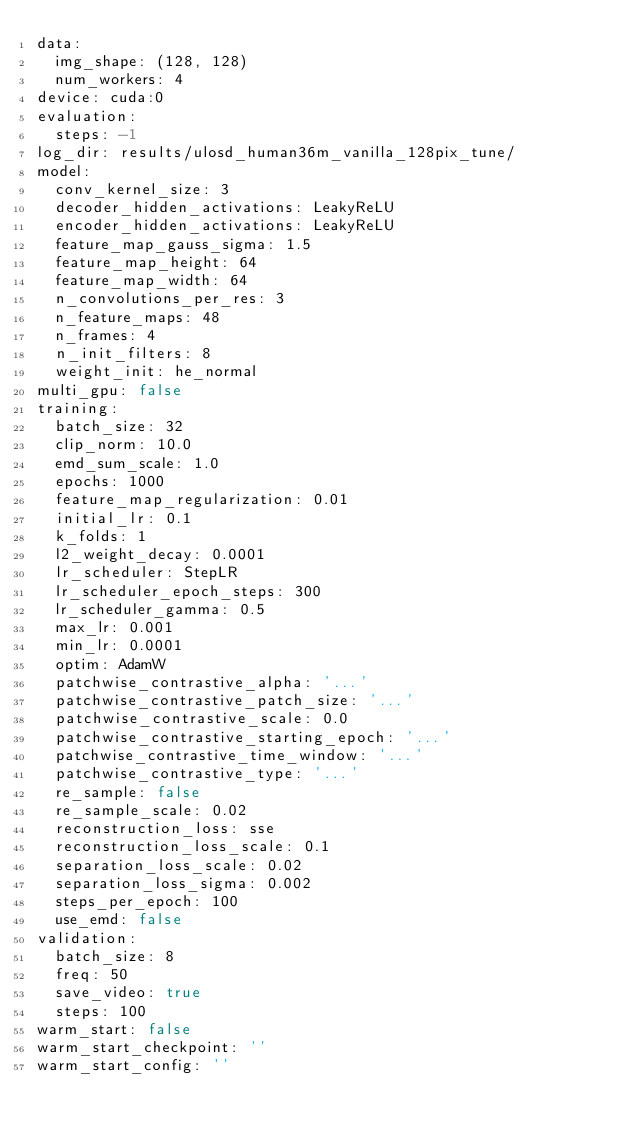Convert code to text. <code><loc_0><loc_0><loc_500><loc_500><_YAML_>data:
  img_shape: (128, 128)
  num_workers: 4
device: cuda:0
evaluation:
  steps: -1
log_dir: results/ulosd_human36m_vanilla_128pix_tune/
model:
  conv_kernel_size: 3
  decoder_hidden_activations: LeakyReLU
  encoder_hidden_activations: LeakyReLU
  feature_map_gauss_sigma: 1.5
  feature_map_height: 64
  feature_map_width: 64
  n_convolutions_per_res: 3
  n_feature_maps: 48
  n_frames: 4
  n_init_filters: 8
  weight_init: he_normal
multi_gpu: false
training:
  batch_size: 32
  clip_norm: 10.0
  emd_sum_scale: 1.0
  epochs: 1000
  feature_map_regularization: 0.01
  initial_lr: 0.1
  k_folds: 1
  l2_weight_decay: 0.0001
  lr_scheduler: StepLR
  lr_scheduler_epoch_steps: 300
  lr_scheduler_gamma: 0.5
  max_lr: 0.001
  min_lr: 0.0001
  optim: AdamW
  patchwise_contrastive_alpha: '...'
  patchwise_contrastive_patch_size: '...'
  patchwise_contrastive_scale: 0.0
  patchwise_contrastive_starting_epoch: '...'
  patchwise_contrastive_time_window: '...'
  patchwise_contrastive_type: '...'
  re_sample: false
  re_sample_scale: 0.02
  reconstruction_loss: sse
  reconstruction_loss_scale: 0.1
  separation_loss_scale: 0.02
  separation_loss_sigma: 0.002
  steps_per_epoch: 100
  use_emd: false
validation:
  batch_size: 8
  freq: 50
  save_video: true
  steps: 100
warm_start: false
warm_start_checkpoint: ''
warm_start_config: ''
</code> 